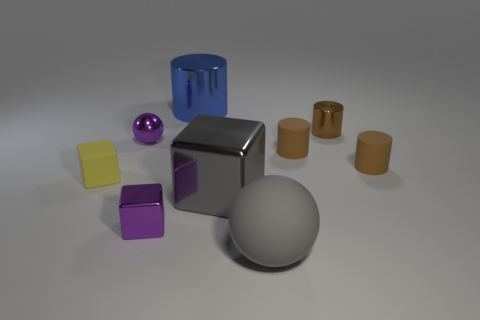Subtract all brown cylinders. How many were subtracted if there are1brown cylinders left? 2 Subtract all purple blocks. How many brown cylinders are left? 3 Subtract all small cylinders. How many cylinders are left? 1 Subtract 1 cubes. How many cubes are left? 2 Subtract all blue cylinders. How many cylinders are left? 3 Subtract all green cylinders. Subtract all gray blocks. How many cylinders are left? 4 Add 1 large blue shiny cylinders. How many objects exist? 10 Subtract all balls. How many objects are left? 7 Add 5 blue metallic objects. How many blue metallic objects are left? 6 Add 9 blue metal balls. How many blue metal balls exist? 9 